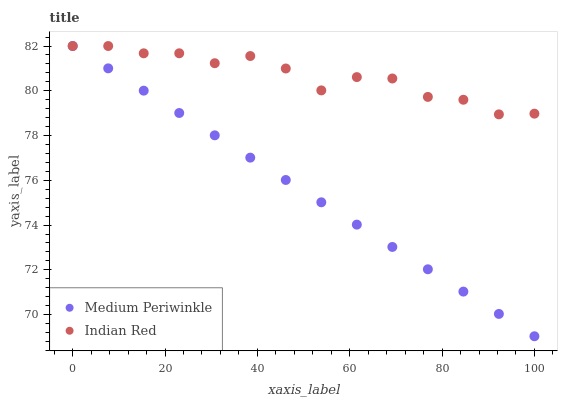Does Medium Periwinkle have the minimum area under the curve?
Answer yes or no. Yes. Does Indian Red have the maximum area under the curve?
Answer yes or no. Yes. Does Indian Red have the minimum area under the curve?
Answer yes or no. No. Is Medium Periwinkle the smoothest?
Answer yes or no. Yes. Is Indian Red the roughest?
Answer yes or no. Yes. Is Indian Red the smoothest?
Answer yes or no. No. Does Medium Periwinkle have the lowest value?
Answer yes or no. Yes. Does Indian Red have the lowest value?
Answer yes or no. No. Does Indian Red have the highest value?
Answer yes or no. Yes. Does Indian Red intersect Medium Periwinkle?
Answer yes or no. Yes. Is Indian Red less than Medium Periwinkle?
Answer yes or no. No. Is Indian Red greater than Medium Periwinkle?
Answer yes or no. No. 